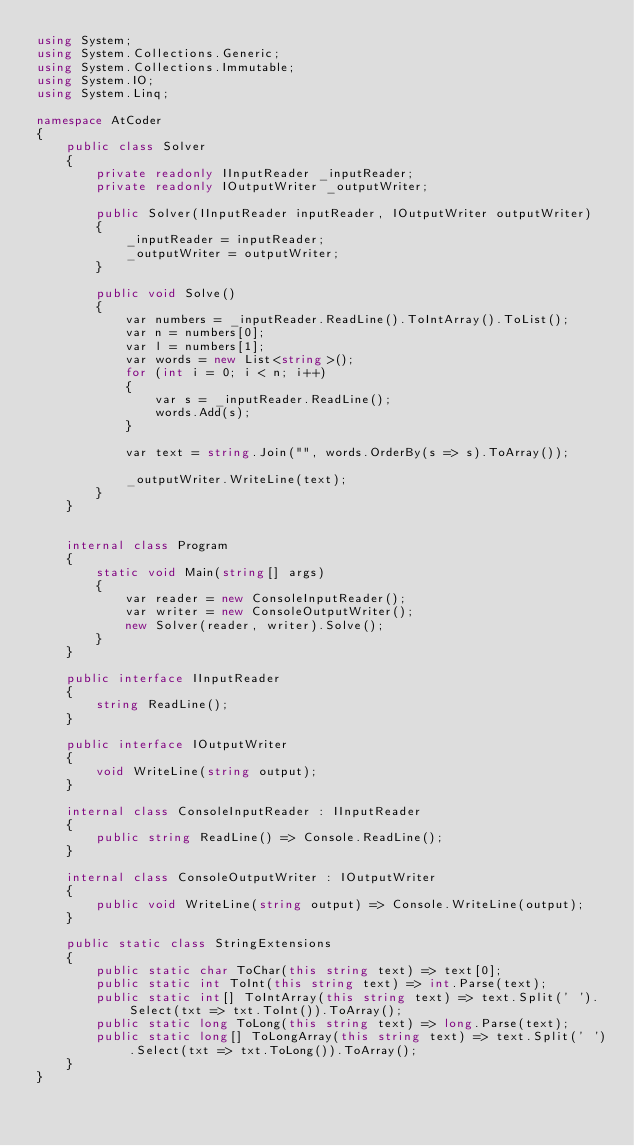Convert code to text. <code><loc_0><loc_0><loc_500><loc_500><_C#_>using System;
using System.Collections.Generic;
using System.Collections.Immutable;
using System.IO;
using System.Linq;

namespace AtCoder
{
    public class Solver
    {
        private readonly IInputReader _inputReader;
        private readonly IOutputWriter _outputWriter;

        public Solver(IInputReader inputReader, IOutputWriter outputWriter)
        {
            _inputReader = inputReader;
            _outputWriter = outputWriter;
        }

        public void Solve()
        {
            var numbers = _inputReader.ReadLine().ToIntArray().ToList();
            var n = numbers[0];
            var l = numbers[1];
            var words = new List<string>();
            for (int i = 0; i < n; i++)
            {
                var s = _inputReader.ReadLine();
                words.Add(s);
            }

            var text = string.Join("", words.OrderBy(s => s).ToArray());

            _outputWriter.WriteLine(text);
        }
    }


    internal class Program
    {
        static void Main(string[] args)
        {
            var reader = new ConsoleInputReader();
            var writer = new ConsoleOutputWriter();
            new Solver(reader, writer).Solve();
        }
    }

    public interface IInputReader
    {
        string ReadLine();
    }

    public interface IOutputWriter
    {
        void WriteLine(string output);
    }

    internal class ConsoleInputReader : IInputReader
    {
        public string ReadLine() => Console.ReadLine();
    }

    internal class ConsoleOutputWriter : IOutputWriter
    {
        public void WriteLine(string output) => Console.WriteLine(output);
    }

    public static class StringExtensions
    {
        public static char ToChar(this string text) => text[0];
        public static int ToInt(this string text) => int.Parse(text);
        public static int[] ToIntArray(this string text) => text.Split(' ').Select(txt => txt.ToInt()).ToArray();
        public static long ToLong(this string text) => long.Parse(text);
        public static long[] ToLongArray(this string text) => text.Split(' ').Select(txt => txt.ToLong()).ToArray();
    }
}</code> 